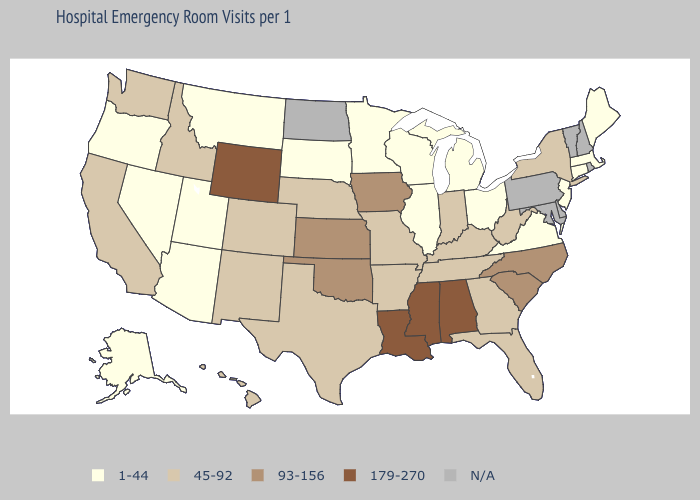Among the states that border Pennsylvania , does West Virginia have the lowest value?
Concise answer only. No. Among the states that border Montana , does South Dakota have the lowest value?
Concise answer only. Yes. Name the states that have a value in the range 93-156?
Keep it brief. Iowa, Kansas, North Carolina, Oklahoma, South Carolina. Name the states that have a value in the range 179-270?
Give a very brief answer. Alabama, Louisiana, Mississippi, Wyoming. Does Wyoming have the highest value in the West?
Short answer required. Yes. Name the states that have a value in the range N/A?
Keep it brief. Delaware, Maryland, New Hampshire, North Dakota, Pennsylvania, Rhode Island, Vermont. Name the states that have a value in the range 45-92?
Write a very short answer. Arkansas, California, Colorado, Florida, Georgia, Hawaii, Idaho, Indiana, Kentucky, Missouri, Nebraska, New Mexico, New York, Tennessee, Texas, Washington, West Virginia. Does Florida have the lowest value in the South?
Answer briefly. No. Does Wyoming have the highest value in the USA?
Be succinct. Yes. What is the value of Iowa?
Keep it brief. 93-156. What is the lowest value in the South?
Give a very brief answer. 1-44. Name the states that have a value in the range 93-156?
Give a very brief answer. Iowa, Kansas, North Carolina, Oklahoma, South Carolina. What is the highest value in the South ?
Concise answer only. 179-270. Name the states that have a value in the range 1-44?
Answer briefly. Alaska, Arizona, Connecticut, Illinois, Maine, Massachusetts, Michigan, Minnesota, Montana, Nevada, New Jersey, Ohio, Oregon, South Dakota, Utah, Virginia, Wisconsin. Does North Carolina have the highest value in the USA?
Give a very brief answer. No. 